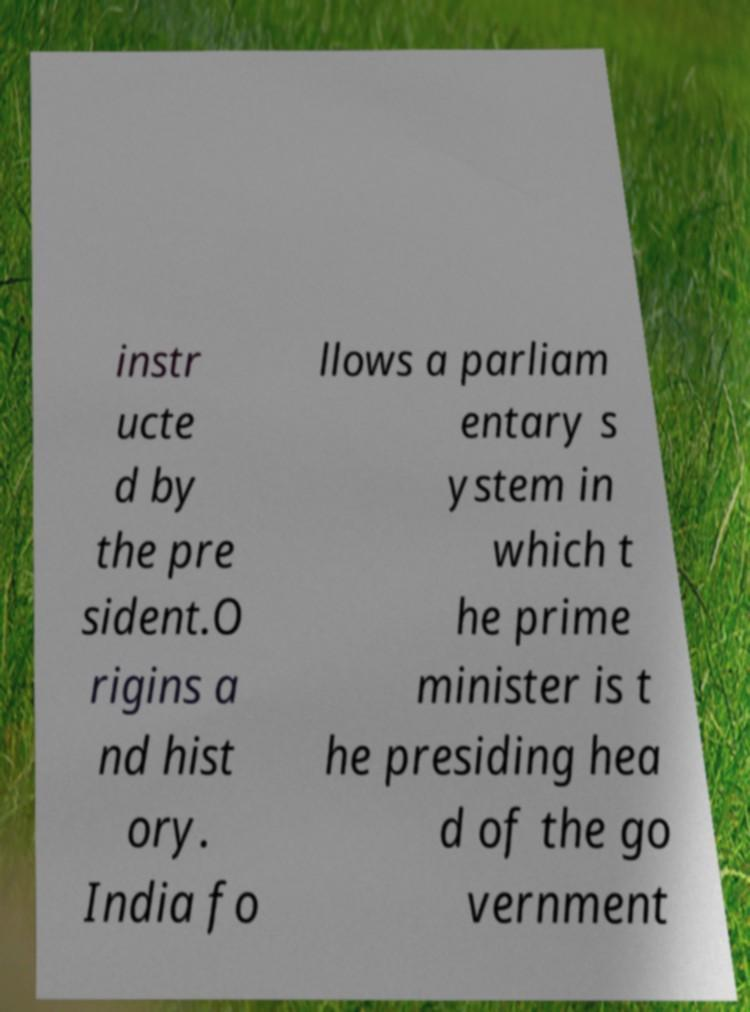Could you assist in decoding the text presented in this image and type it out clearly? instr ucte d by the pre sident.O rigins a nd hist ory. India fo llows a parliam entary s ystem in which t he prime minister is t he presiding hea d of the go vernment 